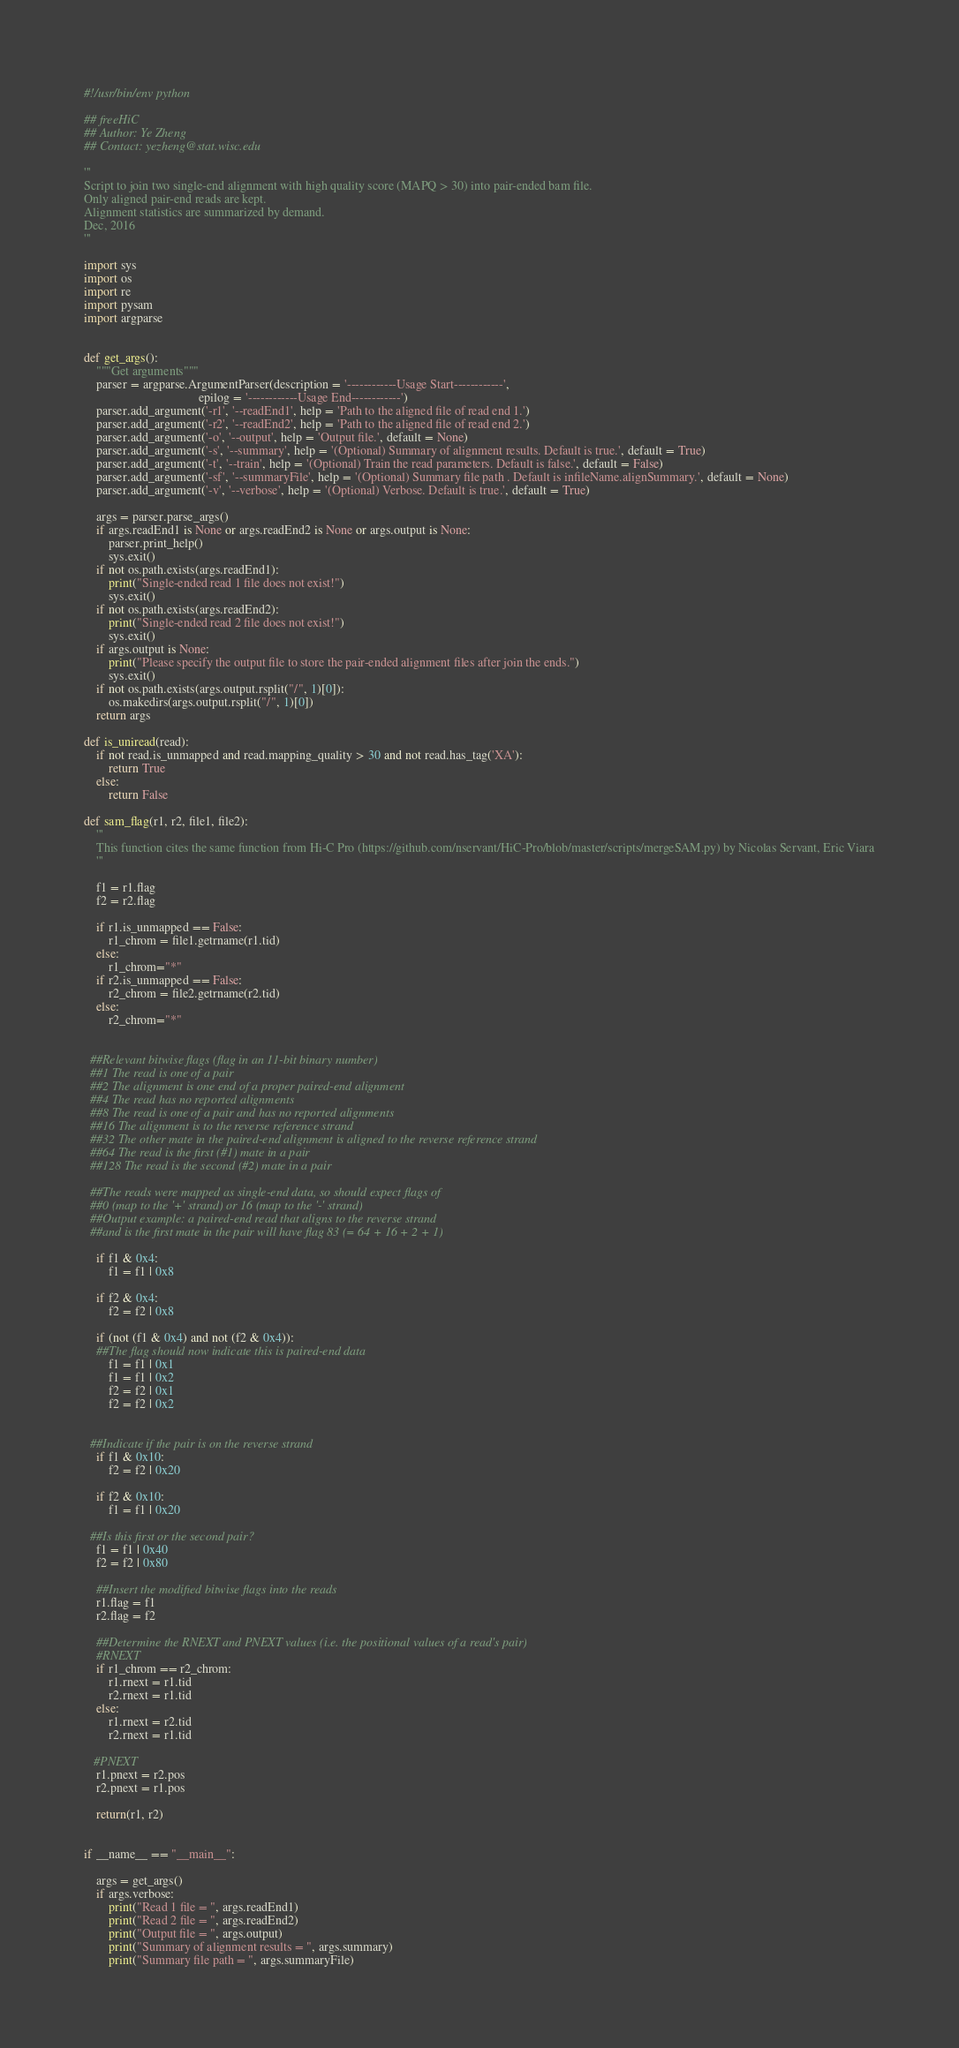Convert code to text. <code><loc_0><loc_0><loc_500><loc_500><_Python_>#!/usr/bin/env python

## freeHiC
## Author: Ye Zheng
## Contact: yezheng@stat.wisc.edu

'''
Script to join two single-end alignment with high quality score (MAPQ > 30) into pair-ended bam file.
Only aligned pair-end reads are kept.
Alignment statistics are summarized by demand.
Dec, 2016
'''

import sys
import os
import re
import pysam
import argparse


def get_args():
    """Get arguments"""
    parser = argparse.ArgumentParser(description = '------------Usage Start------------',
                                     epilog = '------------Usage End------------')
    parser.add_argument('-r1', '--readEnd1', help = 'Path to the aligned file of read end 1.')
    parser.add_argument('-r2', '--readEnd2', help = 'Path to the aligned file of read end 2.')
    parser.add_argument('-o', '--output', help = 'Output file.', default = None)
    parser.add_argument('-s', '--summary', help = '(Optional) Summary of alignment results. Default is true.', default = True)
    parser.add_argument('-t', '--train', help = '(Optional) Train the read parameters. Default is false.', default = False)
    parser.add_argument('-sf', '--summaryFile', help = '(Optional) Summary file path . Default is infileName.alignSummary.', default = None)
    parser.add_argument('-v', '--verbose', help = '(Optional) Verbose. Default is true.', default = True)

    args = parser.parse_args()
    if args.readEnd1 is None or args.readEnd2 is None or args.output is None:
        parser.print_help()
        sys.exit()
    if not os.path.exists(args.readEnd1):
        print("Single-ended read 1 file does not exist!")
        sys.exit()
    if not os.path.exists(args.readEnd2):
        print("Single-ended read 2 file does not exist!")
        sys.exit()
    if args.output is None:
        print("Please specify the output file to store the pair-ended alignment files after join the ends.")
        sys.exit()
    if not os.path.exists(args.output.rsplit("/", 1)[0]):
        os.makedirs(args.output.rsplit("/", 1)[0])
    return args

def is_uniread(read):
    if not read.is_unmapped and read.mapping_quality > 30 and not read.has_tag('XA'):
        return True
    else:
        return False

def sam_flag(r1, r2, file1, file2):
    '''
    This function cites the same function from Hi-C Pro (https://github.com/nservant/HiC-Pro/blob/master/scripts/mergeSAM.py) by Nicolas Servant, Eric Viara
    '''

    f1 = r1.flag
    f2 = r2.flag

    if r1.is_unmapped == False:
        r1_chrom = file1.getrname(r1.tid)
    else:
        r1_chrom="*"
    if r2.is_unmapped == False:
        r2_chrom = file2.getrname(r2.tid)
    else:
        r2_chrom="*"


  ##Relevant bitwise flags (flag in an 11-bit binary number)
  ##1 The read is one of a pair
  ##2 The alignment is one end of a proper paired-end alignment
  ##4 The read has no reported alignments
  ##8 The read is one of a pair and has no reported alignments
  ##16 The alignment is to the reverse reference strand
  ##32 The other mate in the paired-end alignment is aligned to the reverse reference strand
  ##64 The read is the first (#1) mate in a pair
  ##128 The read is the second (#2) mate in a pair
  
  ##The reads were mapped as single-end data, so should expect flags of 
  ##0 (map to the '+' strand) or 16 (map to the '-' strand)
  ##Output example: a paired-end read that aligns to the reverse strand 
  ##and is the first mate in the pair will have flag 83 (= 64 + 16 + 2 + 1)
  
    if f1 & 0x4:
        f1 = f1 | 0x8

    if f2 & 0x4:
        f2 = f2 | 0x8
    
    if (not (f1 & 0x4) and not (f2 & 0x4)):
    ##The flag should now indicate this is paired-end data
        f1 = f1 | 0x1
        f1 = f1 | 0x2
        f2 = f2 | 0x1
        f2 = f2 | 0x2
  
    
  ##Indicate if the pair is on the reverse strand
    if f1 & 0x10:
        f2 = f2 | 0x20
  
    if f2 & 0x10:
        f1 = f1 | 0x20
  
  ##Is this first or the second pair?
    f1 = f1 | 0x40
    f2 = f2 | 0x80
  
    ##Insert the modified bitwise flags into the reads
    r1.flag = f1
    r2.flag = f2

    ##Determine the RNEXT and PNEXT values (i.e. the positional values of a read's pair)
    #RNEXT
    if r1_chrom == r2_chrom:
        r1.rnext = r1.tid
        r2.rnext = r1.tid
    else:
        r1.rnext = r2.tid
        r2.rnext = r1.tid
   
   #PNEXT
    r1.pnext = r2.pos
    r2.pnext = r1.pos
 
    return(r1, r2)


if __name__ == "__main__":

    args = get_args()
    if args.verbose:
        print("Read 1 file = ", args.readEnd1)
        print("Read 2 file = ", args.readEnd2)
        print("Output file = ", args.output)
        print("Summary of alignment results = ", args.summary)
        print("Summary file path = ", args.summaryFile)</code> 